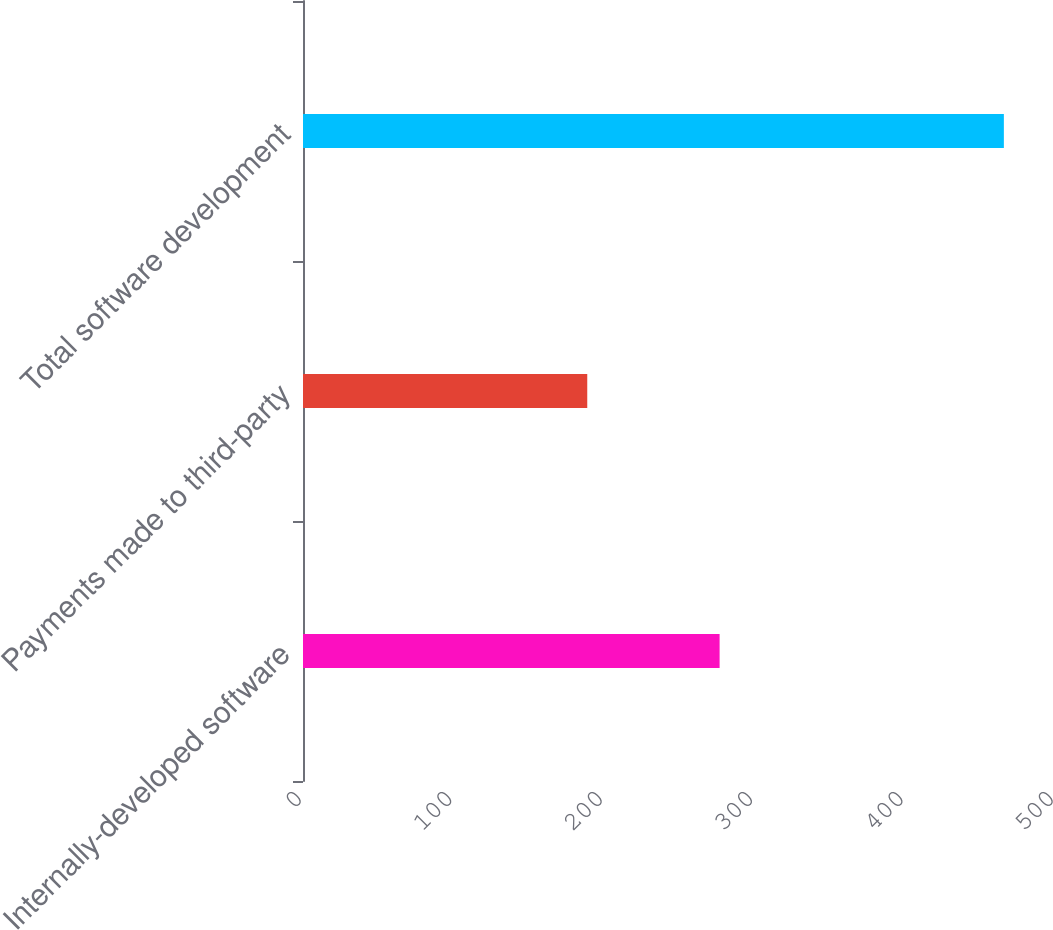Convert chart to OTSL. <chart><loc_0><loc_0><loc_500><loc_500><bar_chart><fcel>Internally-developed software<fcel>Payments made to third-party<fcel>Total software development<nl><fcel>277<fcel>189<fcel>466<nl></chart> 